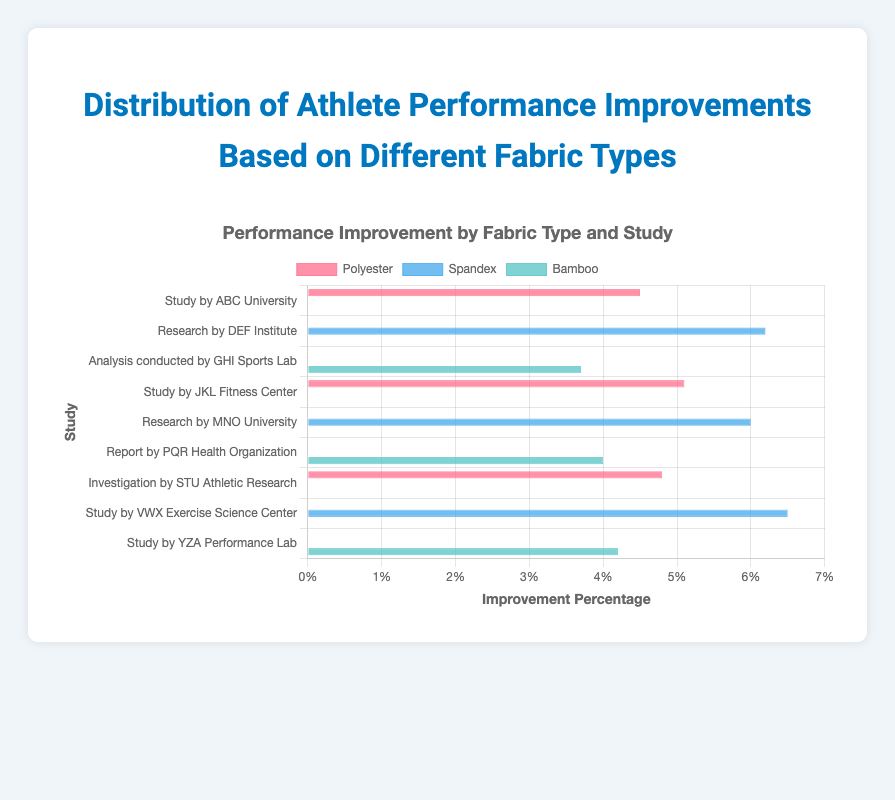Which fabric type shows the highest improvement percentage overall? By examining the bar chart and comparing the bars for each fabric type, it is clear that the Spandex bars are generally the longest, indicating higher improvement percentages.
Answer: Spandex Which study observed the highest improvement percentage and what was the fabric type? The chart shows the longest bar corresponds to the "Study by VWX Exercise Science Center," and it is color-coded for Spandex, indicating this study observed the highest improvement percentage.
Answer: Study by VWX Exercise Science Center and Spandex What are the average improvement percentages for each fabric type? To get the averages:
Polyester: (4.5 + 5.1 + 4.8) / 3 = 4.8%
Spandex: (6.2 + 6.0 + 6.5) / 3 = 6.23%
Bamboo: (3.7 + 4.0 + 4.2) / 3 = 3.97%
Answer: Polyester: 4.8%, Spandex: 6.23%, Bamboo: 3.97% Is there a study with an improvement percentage that falls below 4%? If so, which one? The only bar that shows an improvement percentage below 4% is for the "Analysis conducted by GHI Sports Lab," coded in the color for Bamboo.
Answer: Analysis conducted by GHI Sports Lab Which study has the smallest difference in improvement percentages between the two fabric types it tested, and what are those differences? By identifying the studies that tested more than one fabric type:
No studies compare two fabric types directly, all studies seem to test one specific fabric type only, thus the difference question doesn't apply to the given chart.
Answer: None Compare the largest improvement percentage for Bamboo with the smallest improvement percentage for Spandex. The largest improvement percentage for Bamboo is 4.2% (YZA Performance Lab) and the smallest for Spandex is 6.0% (MNO University). Bamboo's largest is less than Spandex's smallest.
Answer: Bamboo: 4.2%, Spandex: 6.0% Which fabric type generally shows the least improvement? By visual inspection of the chart, Bamboo has the shortest bars on average, indicating it generally shows the least improvement.
Answer: Bamboo What is the range of performance improvements for Polyester? The lowest improvement percentage for Polyester is 4.5% (ABC University) and the highest is 5.1% (JKL Fitness Center), so the range is 5.1% - 4.5% = 0.6%.
Answer: 0.6% What fabric and study combination shows a 4.8% improvement? The 4.8% improvement is shown by Polyester in the study from "Investigation by STU Athletic Research."
Answer: Polyester in Investigation by STU Athletic Research 